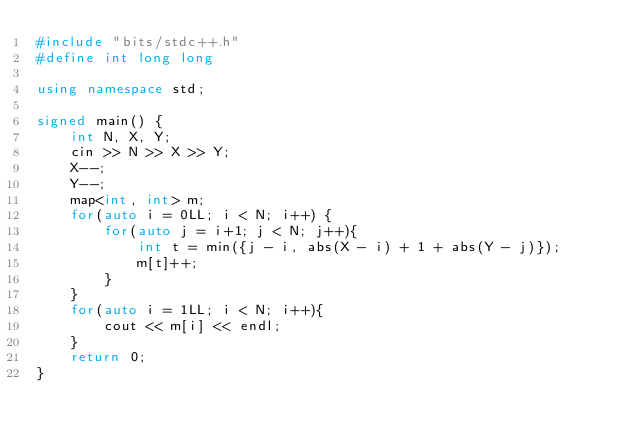Convert code to text. <code><loc_0><loc_0><loc_500><loc_500><_C++_>#include "bits/stdc++.h"
#define int long long

using namespace std;

signed main() {
    int N, X, Y;
    cin >> N >> X >> Y;
    X--;
    Y--;
    map<int, int> m;
    for(auto i = 0LL; i < N; i++) {
        for(auto j = i+1; j < N; j++){
            int t = min({j - i, abs(X - i) + 1 + abs(Y - j)});
            m[t]++;
        }
    }
    for(auto i = 1LL; i < N; i++){
        cout << m[i] << endl;
    }
    return 0;
}</code> 